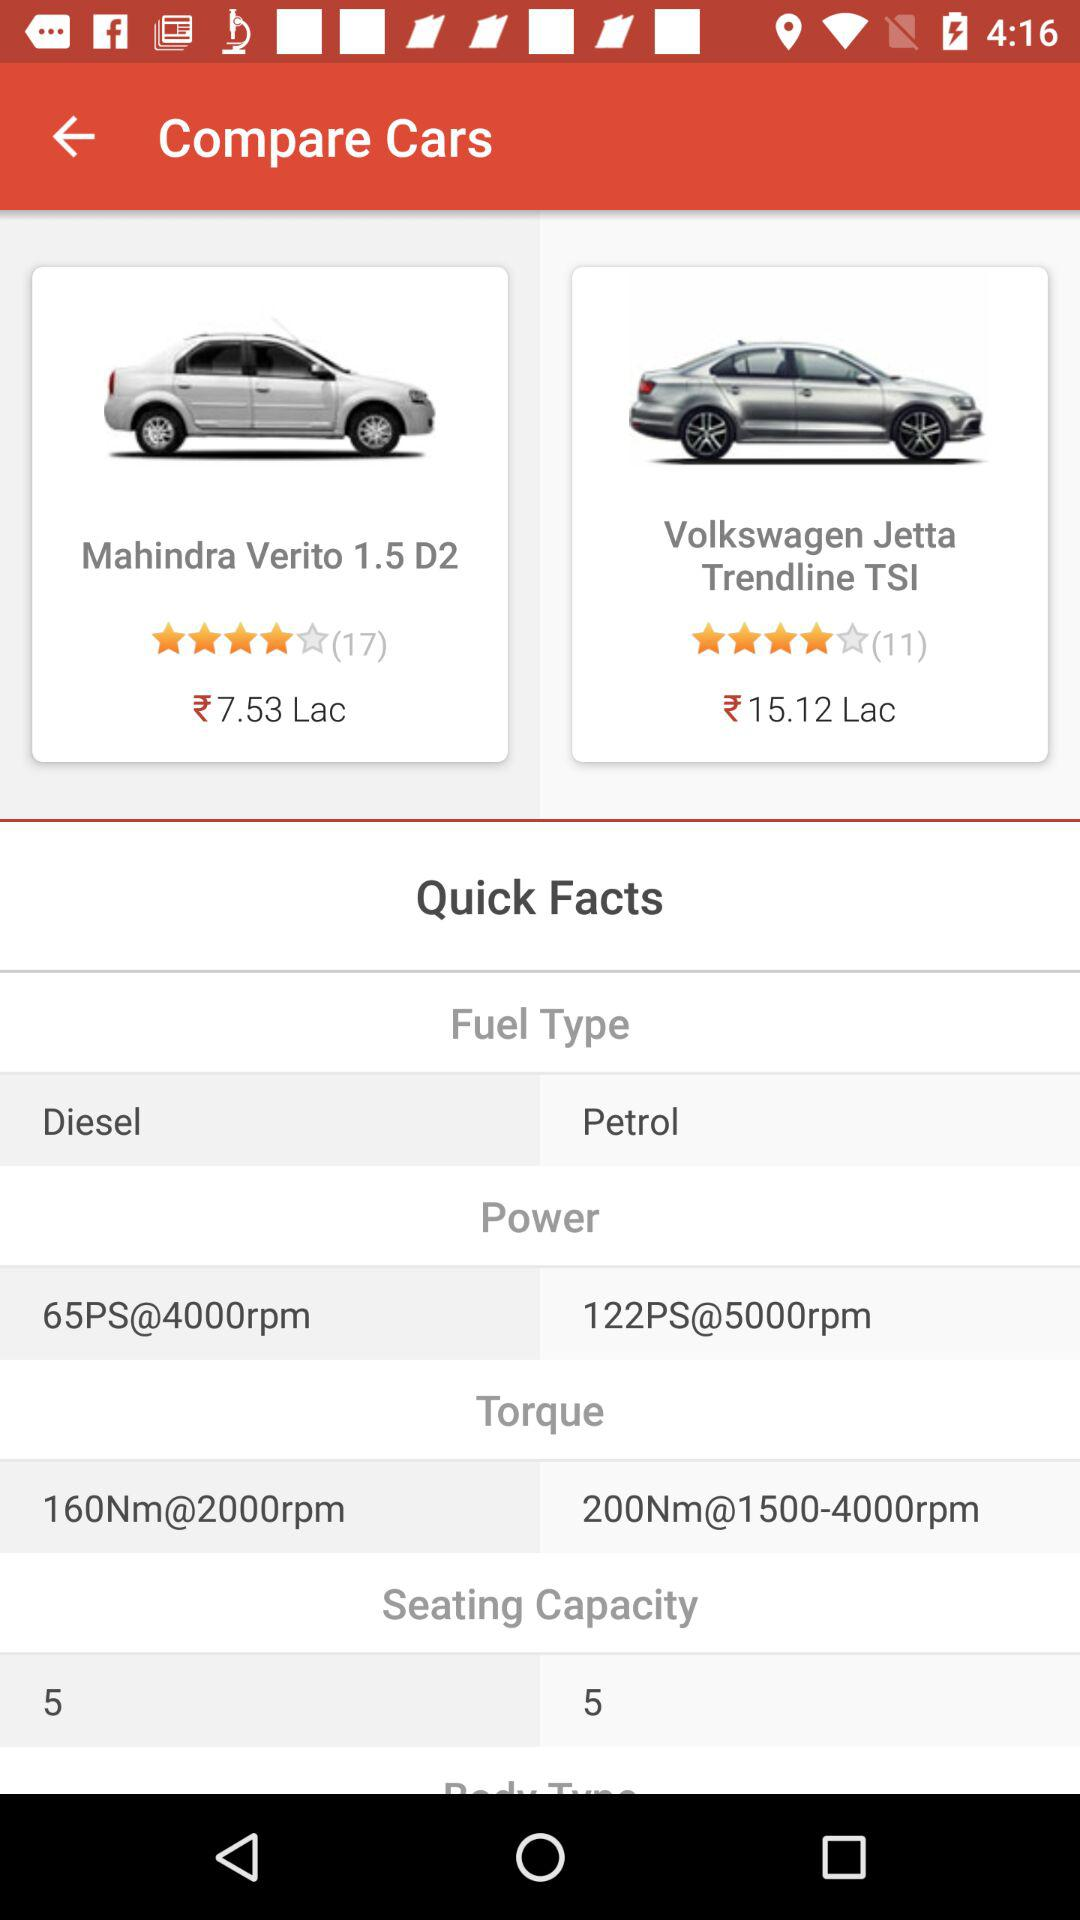Which car has a higher power output, the Mahindra Verito 1.5 D2 or the Volkswagen Jetta Trendline TSI?
Answer the question using a single word or phrase. Volkswagen Jetta Trendline TSI 